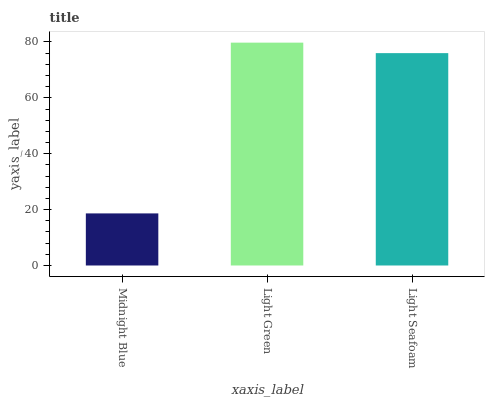Is Midnight Blue the minimum?
Answer yes or no. Yes. Is Light Green the maximum?
Answer yes or no. Yes. Is Light Seafoam the minimum?
Answer yes or no. No. Is Light Seafoam the maximum?
Answer yes or no. No. Is Light Green greater than Light Seafoam?
Answer yes or no. Yes. Is Light Seafoam less than Light Green?
Answer yes or no. Yes. Is Light Seafoam greater than Light Green?
Answer yes or no. No. Is Light Green less than Light Seafoam?
Answer yes or no. No. Is Light Seafoam the high median?
Answer yes or no. Yes. Is Light Seafoam the low median?
Answer yes or no. Yes. Is Midnight Blue the high median?
Answer yes or no. No. Is Midnight Blue the low median?
Answer yes or no. No. 